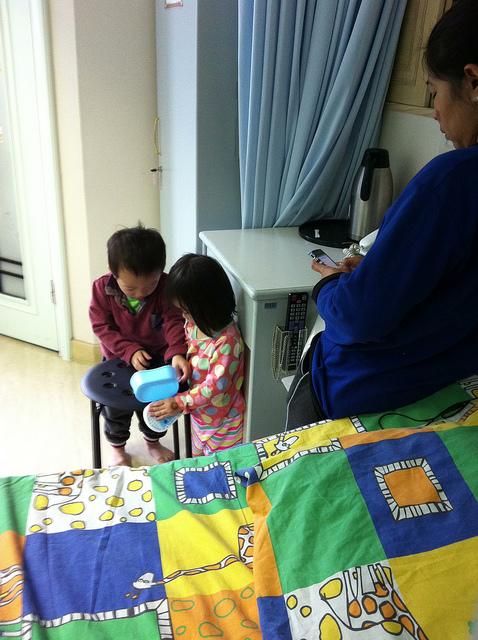How many people can be seen?
Quick response, please. 3. What is the little girl holding that is blue?
Keep it brief. Toy. Where is the remote?
Keep it brief. Side of table. 